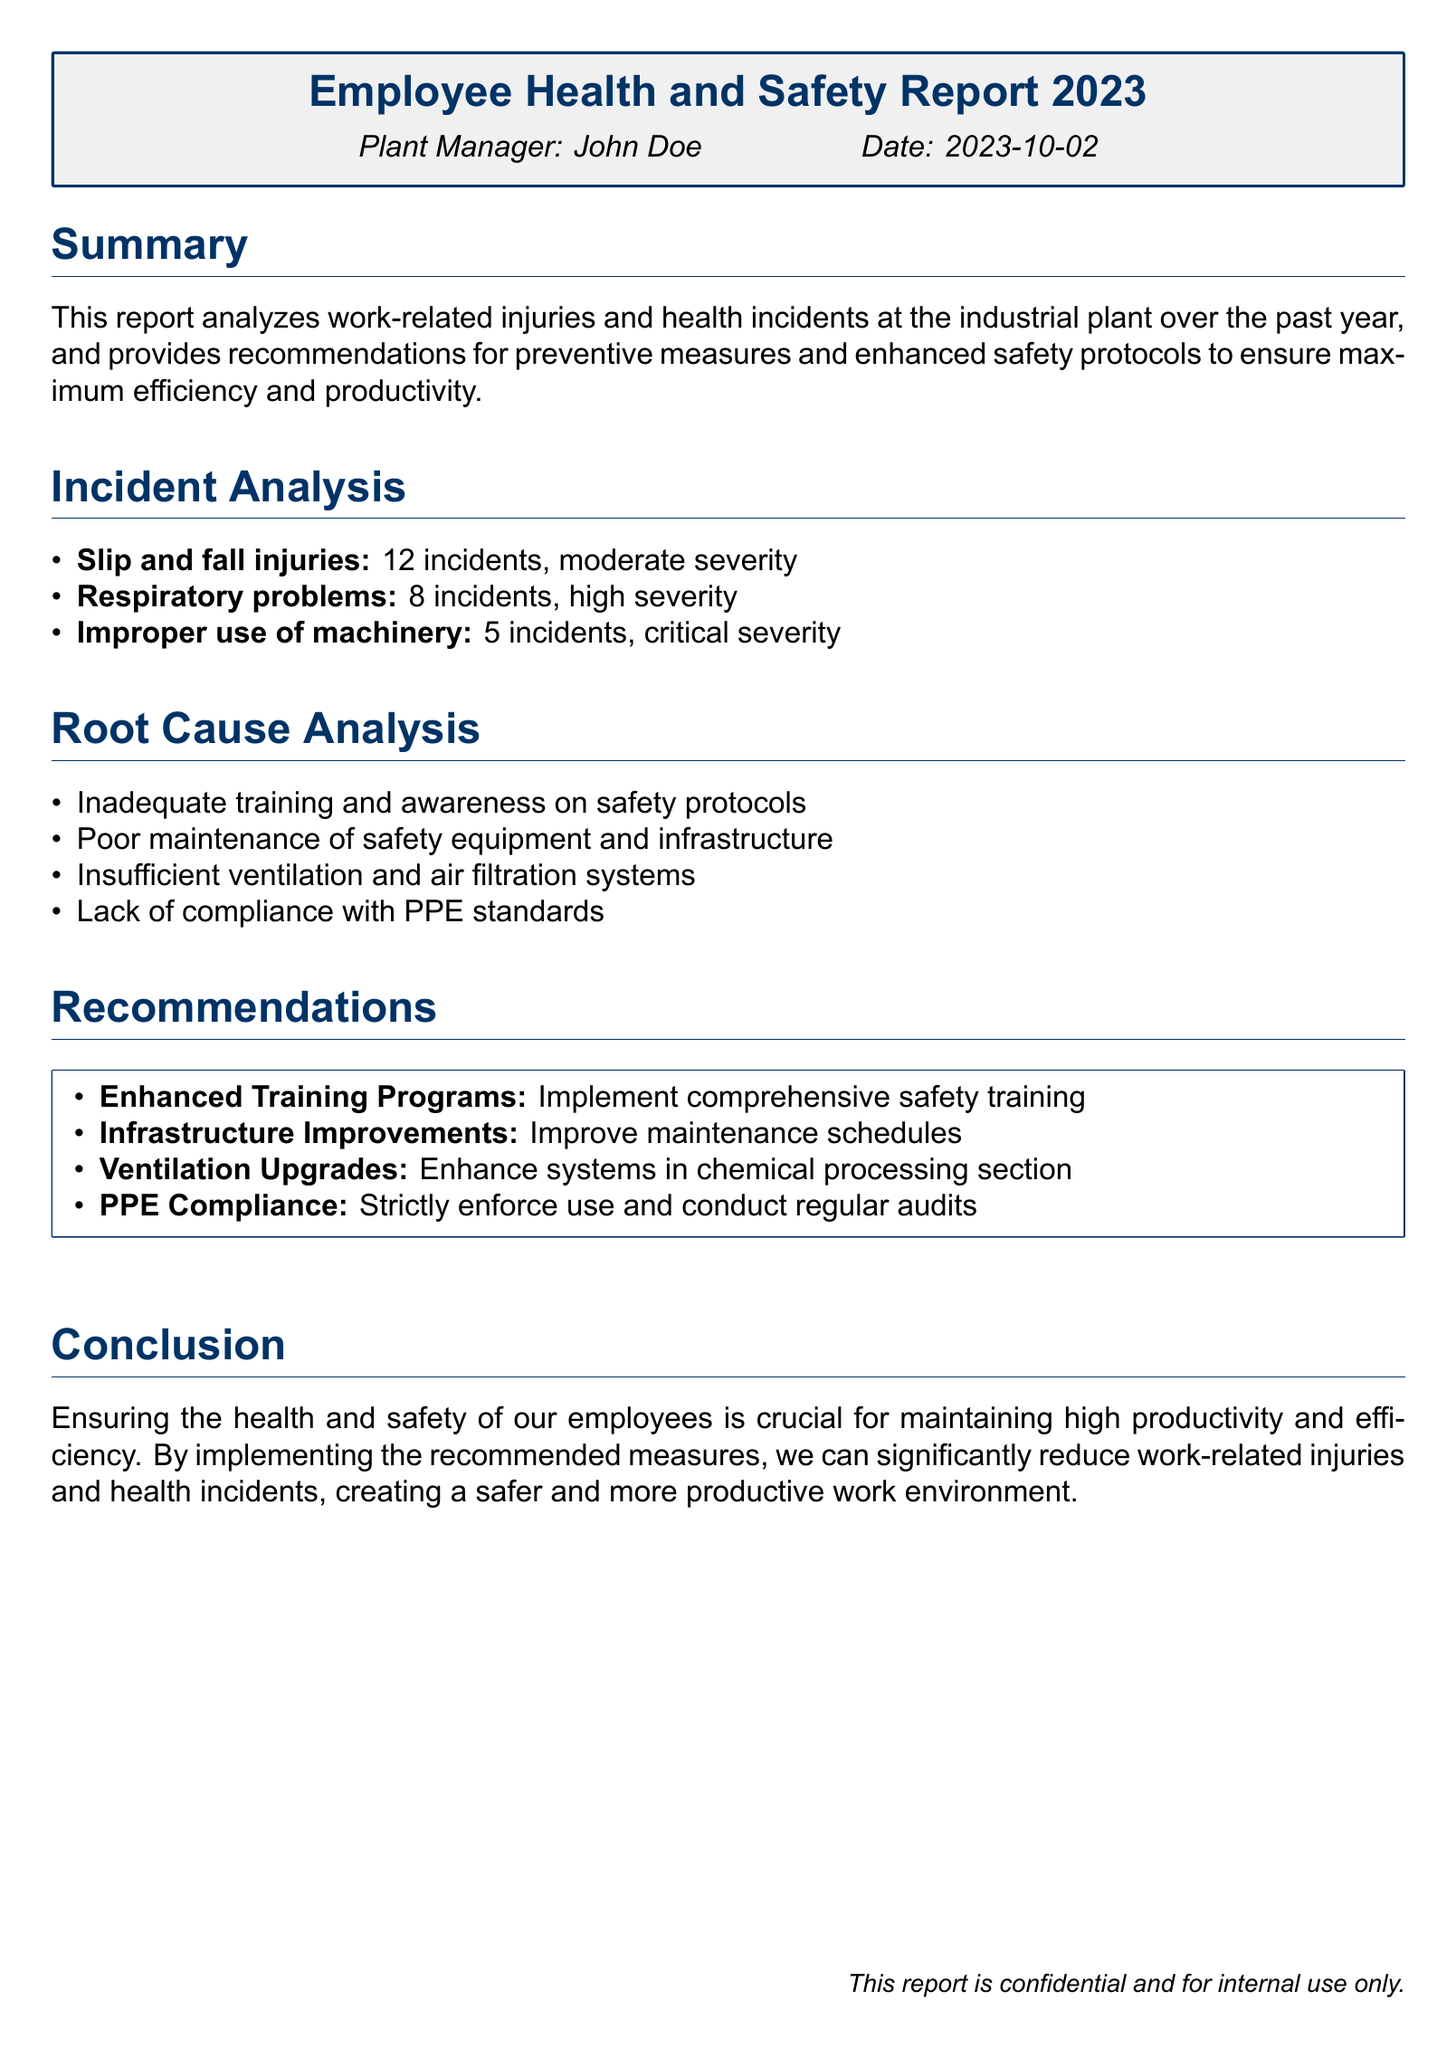What is the total number of slip and fall injuries reported? The document states there were 12 incidents of slip and fall injuries listed in the incident analysis.
Answer: 12 What is the severity level of respiratory problems? The report categorizes respiratory problems as high severity in the incident analysis section.
Answer: High severity What is one root cause identified for work-related injuries? The report lists inadequate training and awareness on safety protocols as one of the root causes in the root cause analysis section.
Answer: Inadequate training What type of improvements does the report recommend for infrastructure? The recommendations suggest improving maintenance schedules for infrastructure as a preventive measure.
Answer: Improve maintenance schedules How many incidents were related to improper use of machinery? The report indicates there were 5 incidents related to improper use of machinery in the incident analysis.
Answer: 5 What type of compliance is emphasized in the recommendations? The report emphasizes PPE compliance in the recommendations section.
Answer: PPE compliance What is the date of the report? The report is dated October 2, 2023, as mentioned in the header section.
Answer: 2023-10-02 What is the main focus of this report? The main focus of the report is analyzing work-related injuries and health incidents over the past year.
Answer: Analyzing work-related injuries What is the name of the plant manager who authored the report? The document identifies John Doe as the plant manager in the header.
Answer: John Doe 